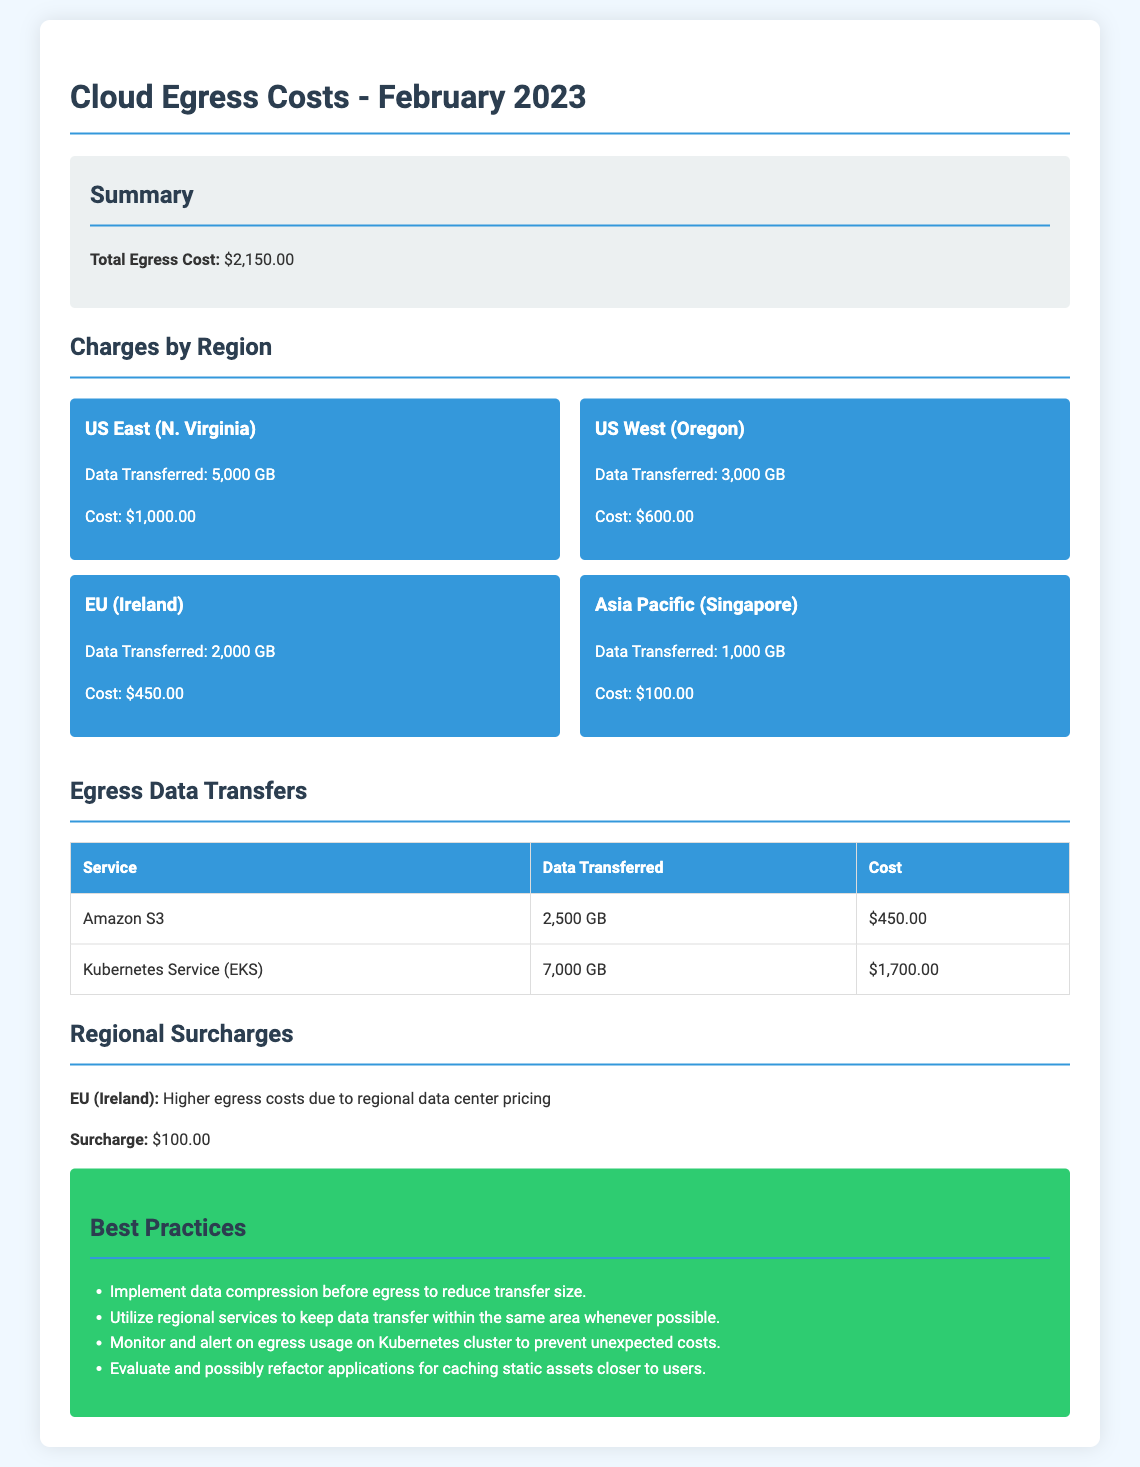What is the total egress cost? The total egress cost is provided in the summary section of the document.
Answer: $2,150.00 How much data was transferred from US East (N. Virginia)? The data transferred is specified in the regional charges section for US East (N. Virginia).
Answer: 5,000 GB What was the cost for data transferred from EU (Ireland)? The cost for EU (Ireland) is listed under the charges by region.
Answer: $450.00 How much data was transferred using Kubernetes Service (EKS)? The data transferred using Kubernetes Service (EKS) is shown in the egress data transfers table.
Answer: 7,000 GB What is the surcharge for the EU (Ireland) region? The surcharge for the EU (Ireland) region is mentioned in the regional surcharges section.
Answer: $100.00 Which service had the highest data transfer amount? We analyze the data in the egress data transfers table to identify the service with the highest data transfer amount.
Answer: Kubernetes Service (EKS) What are two best practices mentioned for optimizing egress cost? The best practices are outlined in the best practices section of the document, highlighting strategies to reduce costs.
Answer: Implement data compression, utilize regional services How many regions are listed with their charges? The number of regions with charges is determined by reviewing the regional charges section.
Answer: 4 What is the total data transferred from all services? To find the total, we sum the data transferred from Amazon S3 and Kubernetes Service (EKS).
Answer: 9,500 GB 